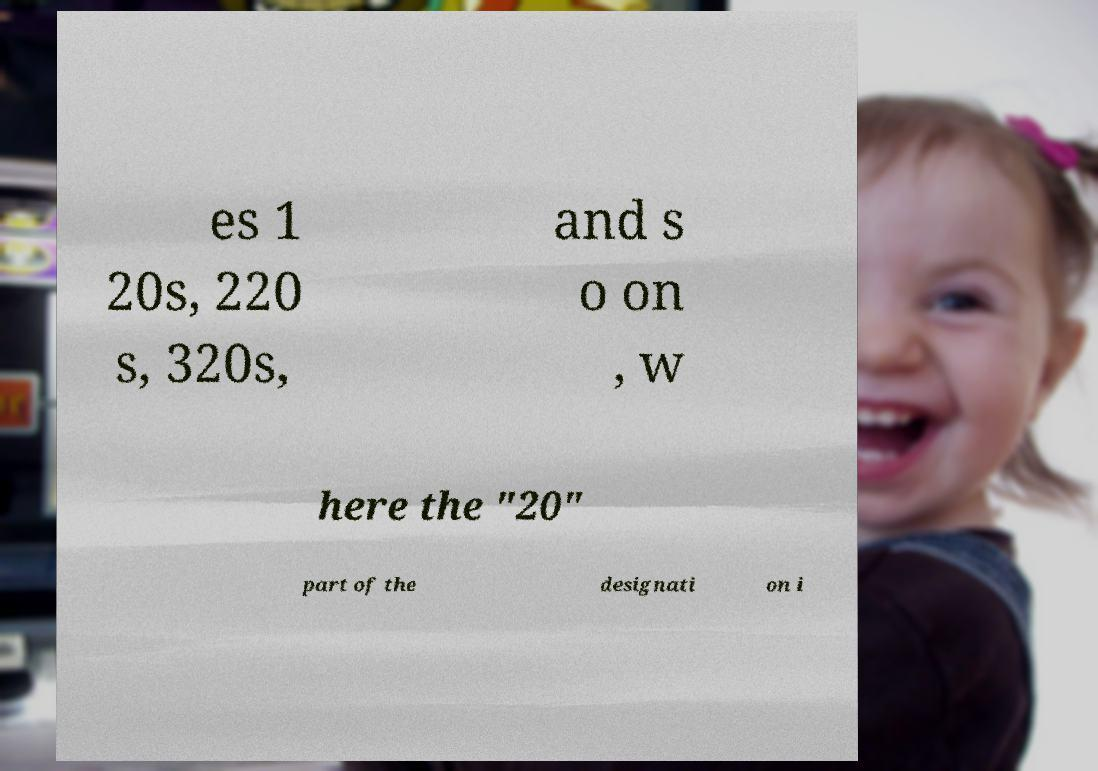Can you accurately transcribe the text from the provided image for me? es 1 20s, 220 s, 320s, and s o on , w here the "20" part of the designati on i 